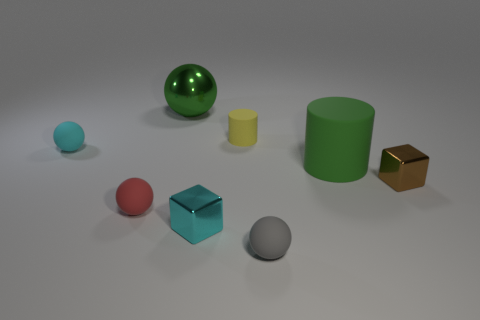Could you estimate the dimensions of the table's surface visible in the image? It's difficult to provide an exact measurement without a reference point, but the table's surface appears to be spacious enough to comfortably hold all the objects with ample space around them, suggesting a moderately large area. 